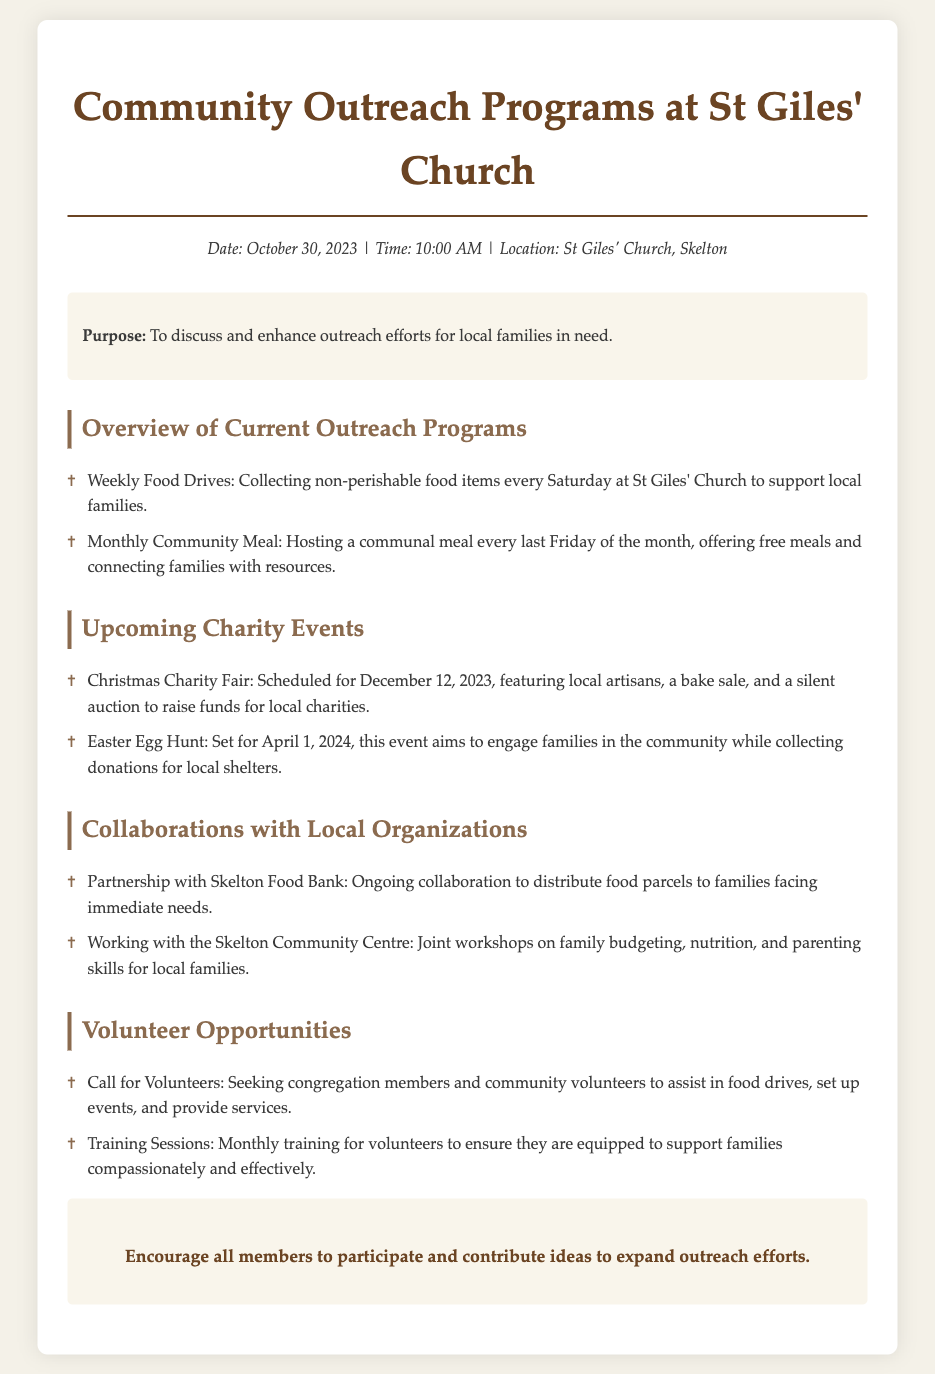What is the date of the Christmas Charity Fair? The date for the Christmas Charity Fair is mentioned in the document.
Answer: December 12, 2023 What type of meal is hosted monthly? The document describes a communal meal held every month.
Answer: Community Meal Which day are food drives conducted? The document states that food drives occur on a specific day each week.
Answer: Saturday How often are training sessions for volunteers held? The document states the frequency of training sessions for volunteers.
Answer: Monthly What is one of the topics covered in workshops with the Skelton Community Centre? The document mentions topics covered in the workshops organized with the local community centre.
Answer: Family budgeting What significant event is scheduled for April 1, 2024? The document specifies an upcoming event that takes place on this date.
Answer: Easter Egg Hunt What is the primary purpose of the agenda? The document states the main goal of the meeting.
Answer: To discuss and enhance outreach efforts Who is partnering with St Giles' Church for food distribution? The document names the organization collaborating with St Giles' Church for food support.
Answer: Skelton Food Bank What is the focus of the monthly community meal? The document explains the intent behind hosting the community meal.
Answer: Offering free meals and connecting families with resources 